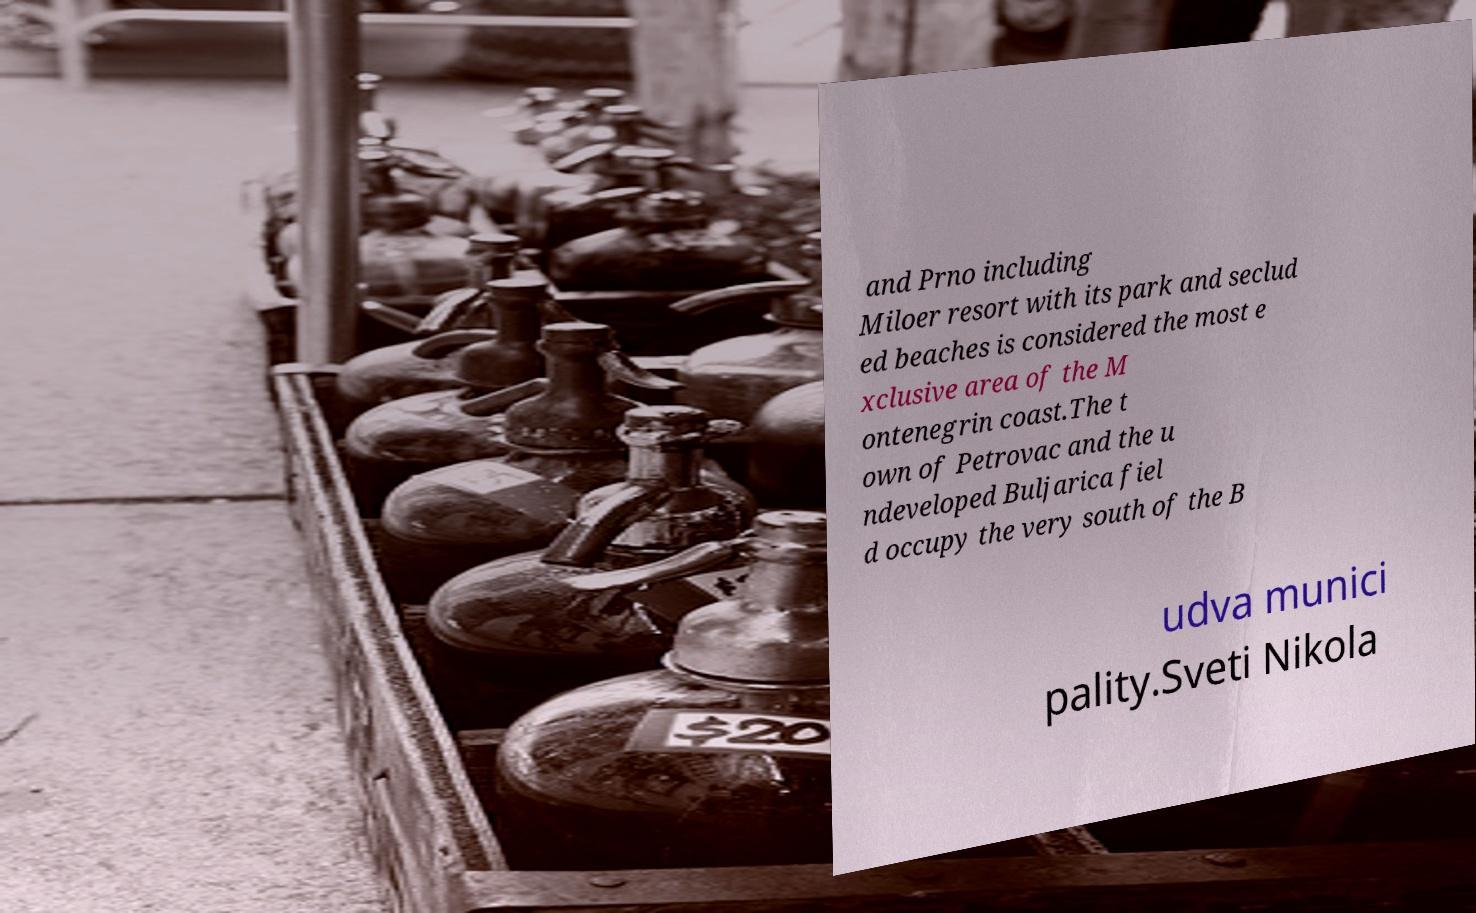Could you assist in decoding the text presented in this image and type it out clearly? and Prno including Miloer resort with its park and seclud ed beaches is considered the most e xclusive area of the M ontenegrin coast.The t own of Petrovac and the u ndeveloped Buljarica fiel d occupy the very south of the B udva munici pality.Sveti Nikola 